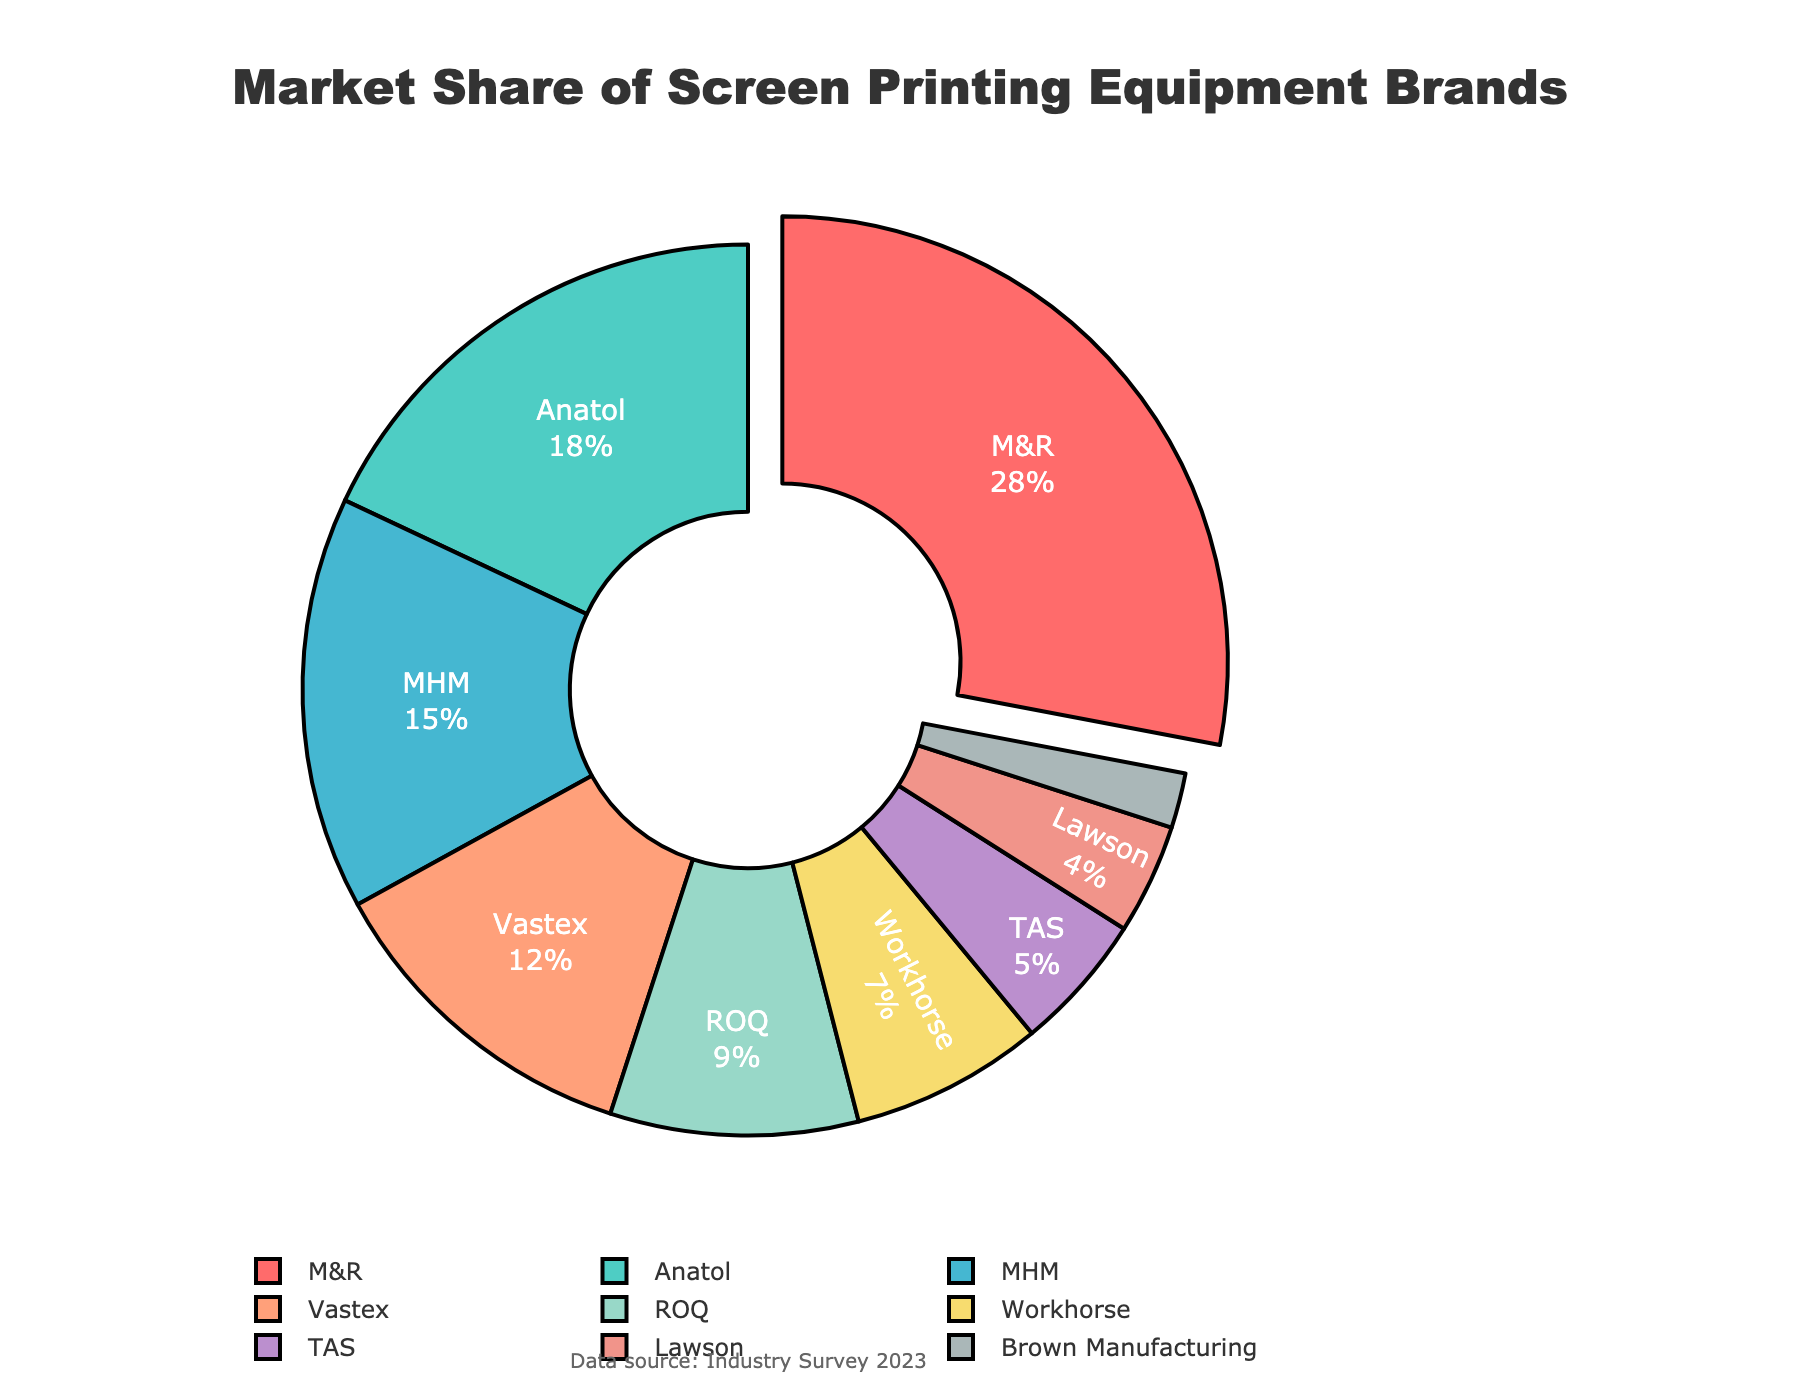Which brand has the highest market share? The brand with the highest market share is shown as the largest segment in the pie chart, which is also pulled out from the rest. It's labeled "M&R" with the largest percentage value.
Answer: M&R What's the combined market share of the top two brands? The top two brands with the highest market shares are "M&R" and "Anatol." M&R has 28% and Anatol has 18%, so the combined market share is 28 + 18 = 46%.
Answer: 46% How much greater is M&R's market share compared to Workhorse's? M&R's market share is 28%, and Workhorse's market share is 7%. The difference is calculated by subtracting Workhorse's share from M&R's share: 28 - 7 = 21%.
Answer: 21% Which brand has the smallest market share, and what is it? The pie chart shows the smallest segment for "Brown Manufacturing" with a market share of 2%.
Answer: Brown Manufacturing, 2% How does Anatol's market share compare to Vastex's? Anatol has a market share of 18%, and Vastex has a market share of 12%. Therefore, Anatol's market share is 6% higher than Vastex's.
Answer: 6% higher What's the average market share of the brands that have more than 10%? The brands with more than 10% market share are M&R (28%), Anatol (18%), and MHM (15%). The average is calculated as (28 + 18 + 15) / 3 = 61 / 3 ≈ 20.33%.
Answer: 20.33% What is the total market share of brands with less than 5%? The brands with less than 5% market share are TAS (5%), Lawson (4%), and Brown Manufacturing (2%). Adding these up: 5 + 4 + 2 = 11%.
Answer: 11% What percentage of the market is captured by brands other than the top three? The top three brands are M&R (28%), Anatol (18%), and MHM (15%). Their combined market share is 28 + 18 + 15 = 61%. Subtract this from 100% to find the market share of the other brands: 100 - 61 = 39%.
Answer: 39% How does the combined market share of ROQ and Lawson compare to that of Vastex? ROQ has 9% and Lawson has 4%, giving them a combined market share of 9 + 4 = 13%. Vastex has a market share of 12%. Thus, ROQ and Lawson together have 1% more market share than Vastex.
Answer: 1% more 